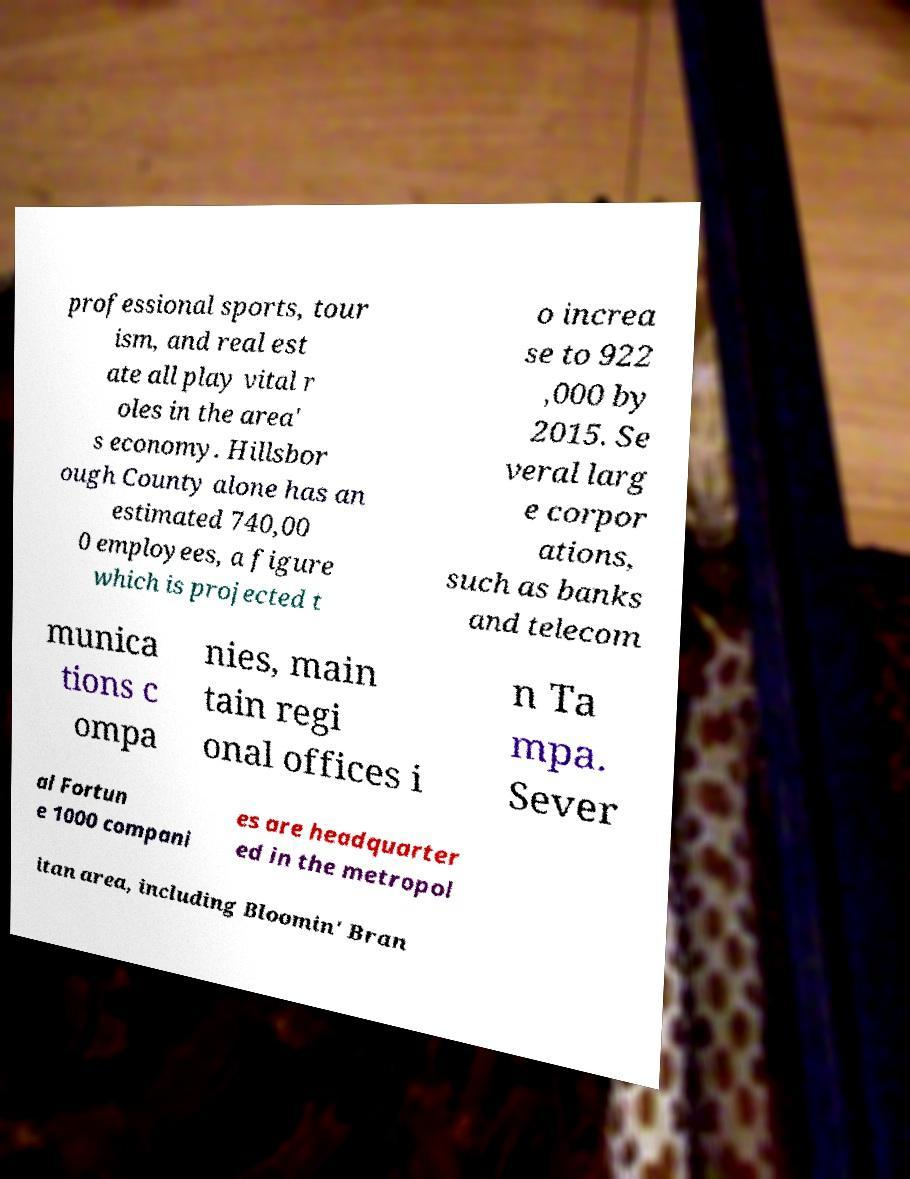For documentation purposes, I need the text within this image transcribed. Could you provide that? professional sports, tour ism, and real est ate all play vital r oles in the area' s economy. Hillsbor ough County alone has an estimated 740,00 0 employees, a figure which is projected t o increa se to 922 ,000 by 2015. Se veral larg e corpor ations, such as banks and telecom munica tions c ompa nies, main tain regi onal offices i n Ta mpa. Sever al Fortun e 1000 compani es are headquarter ed in the metropol itan area, including Bloomin' Bran 